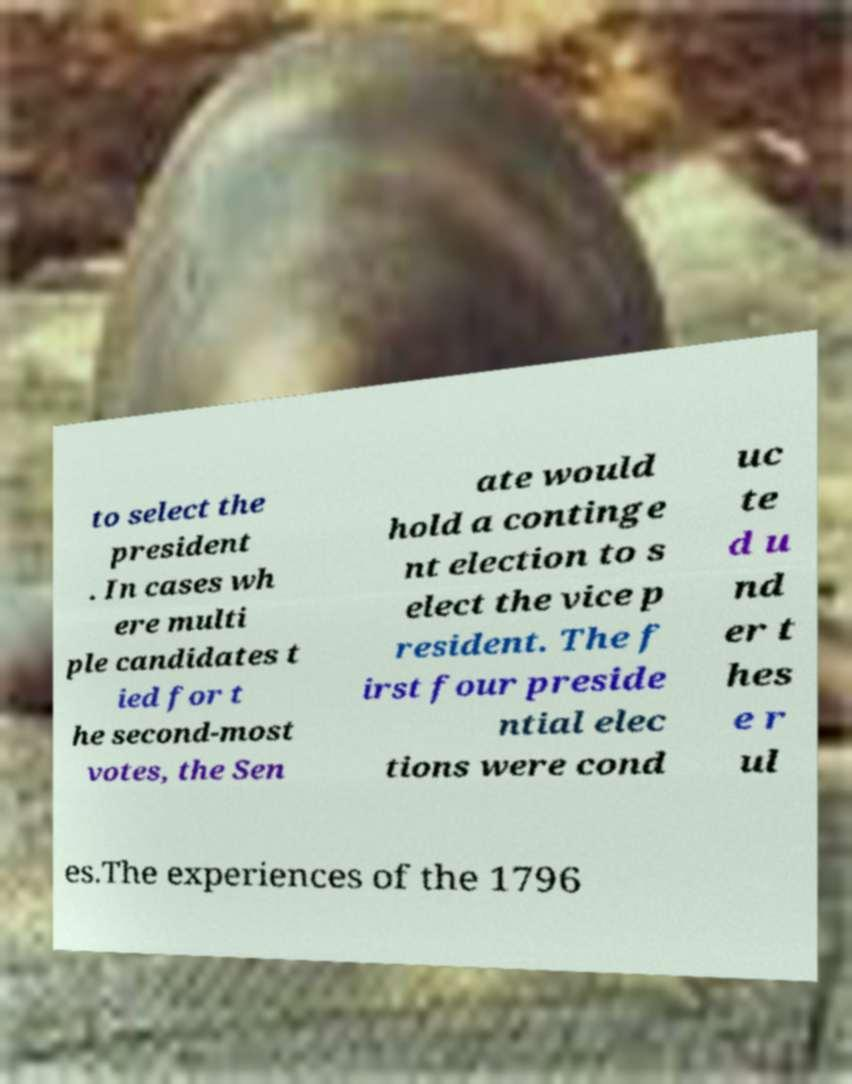I need the written content from this picture converted into text. Can you do that? to select the president . In cases wh ere multi ple candidates t ied for t he second-most votes, the Sen ate would hold a continge nt election to s elect the vice p resident. The f irst four preside ntial elec tions were cond uc te d u nd er t hes e r ul es.The experiences of the 1796 